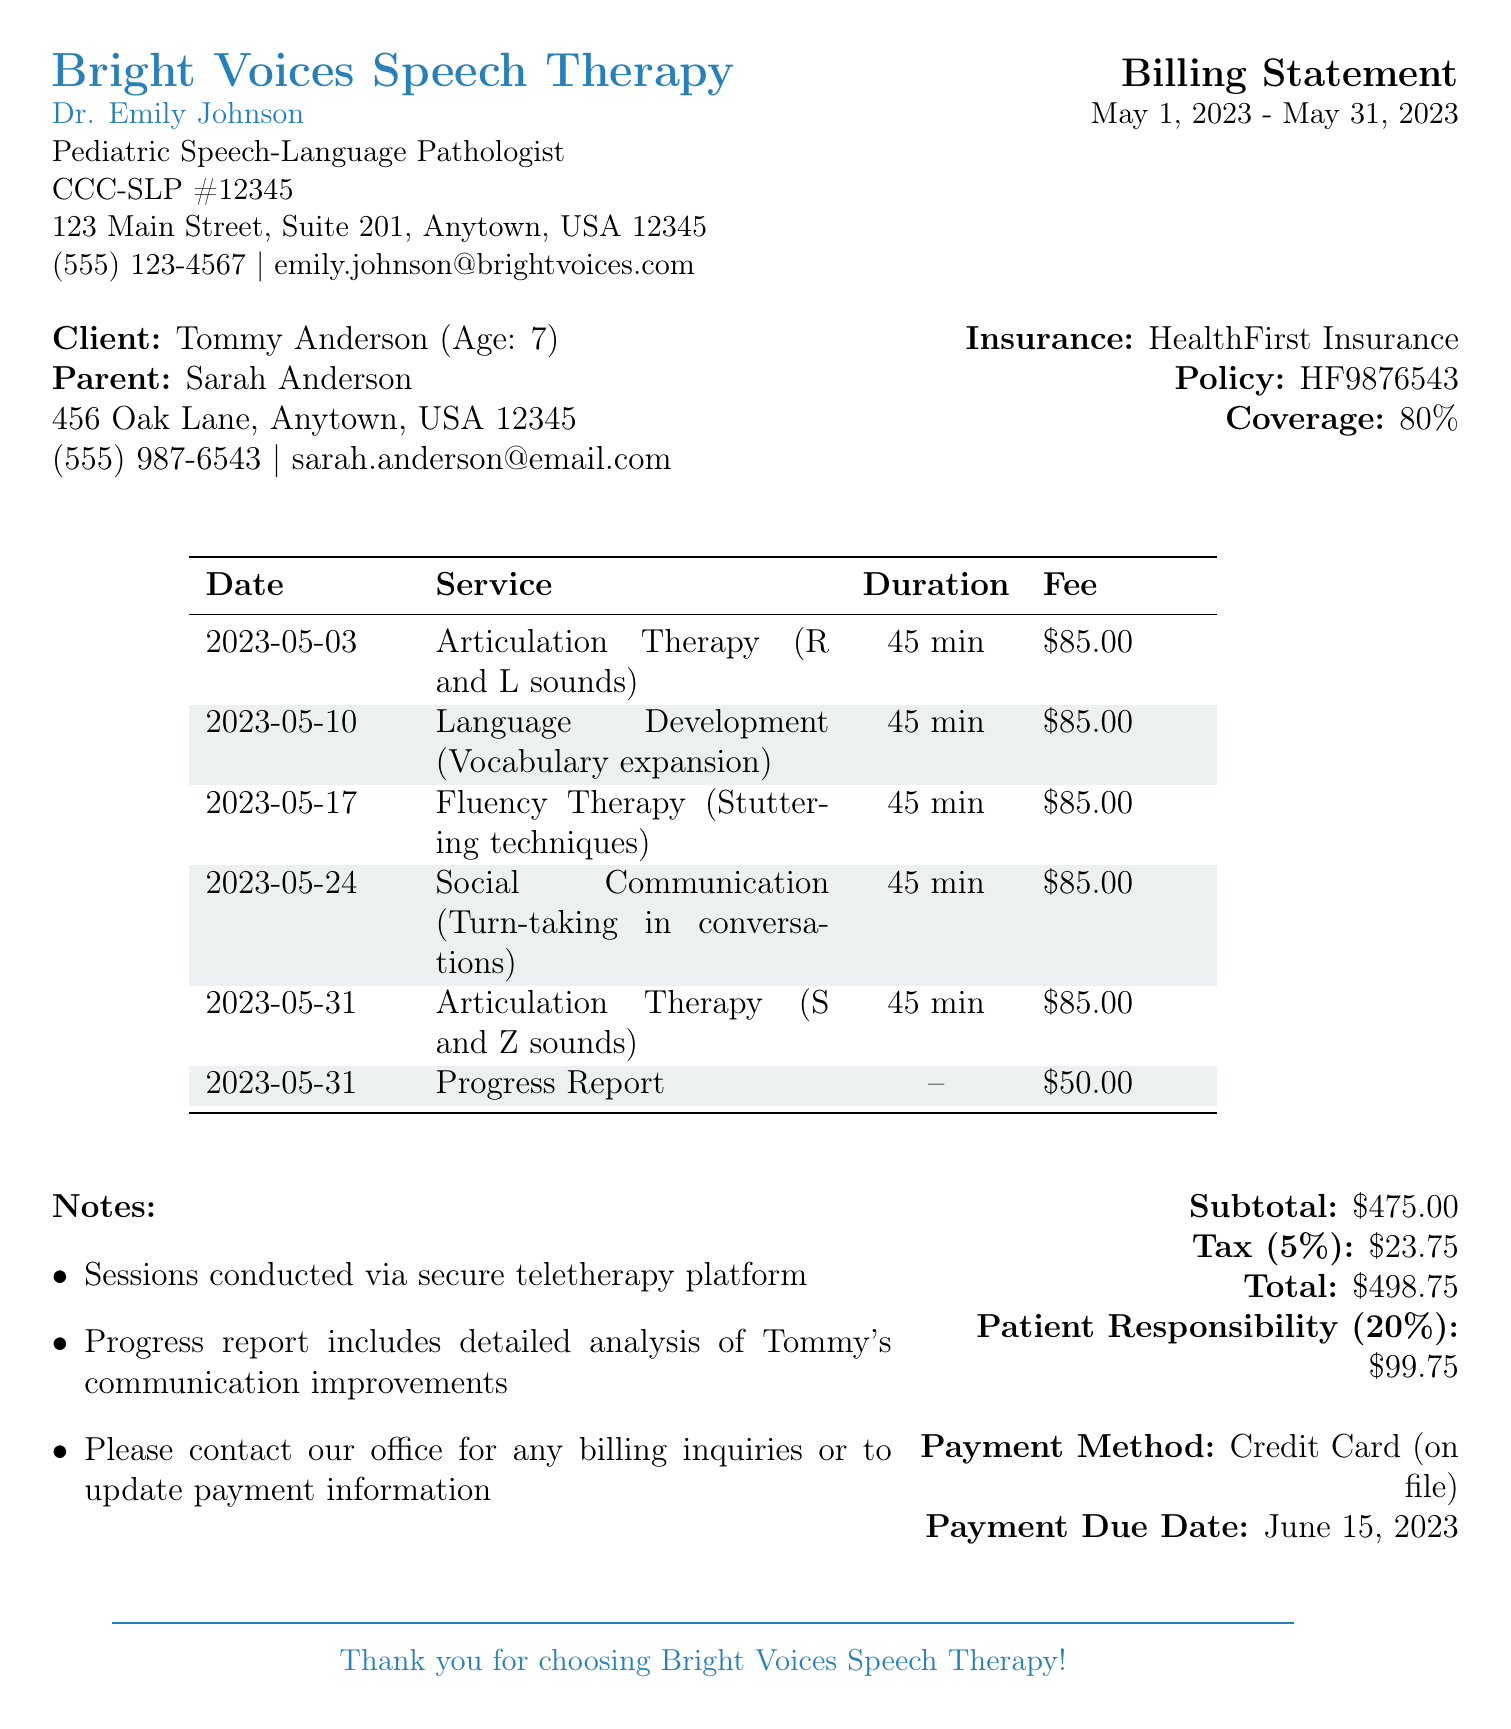What is the name of the therapist? The document provides the name of the therapist as Dr. Emily Johnson.
Answer: Dr. Emily Johnson What is the billing period? The billing period is indicated as starting from May 1, 2023, to May 31, 2023.
Answer: May 1, 2023 - May 31, 2023 How many sessions were conducted in May? By counting the sessions listed in the document, there were five sessions conducted in May.
Answer: 5 What is the total fee charged for services? The total fee charged for services is the total amount calculated, which includes the fee for each session and additional charges.
Answer: 498.75 What type of therapy was conducted on May 10? The document specifies that on May 10, 2023, Language Development therapy was conducted.
Answer: Language Development What is the fee for the Progress Report? The document lists the fee for the Progress Report as fifty dollars.
Answer: 50.00 What percentage of coverage does HealthFirst Insurance provide? The document states that HealthFirst Insurance provides eighty percent coverage.
Answer: 80% What is the payment due date? The payment due date is clearly mentioned in the document as June 15, 2023.
Answer: June 15, 2023 